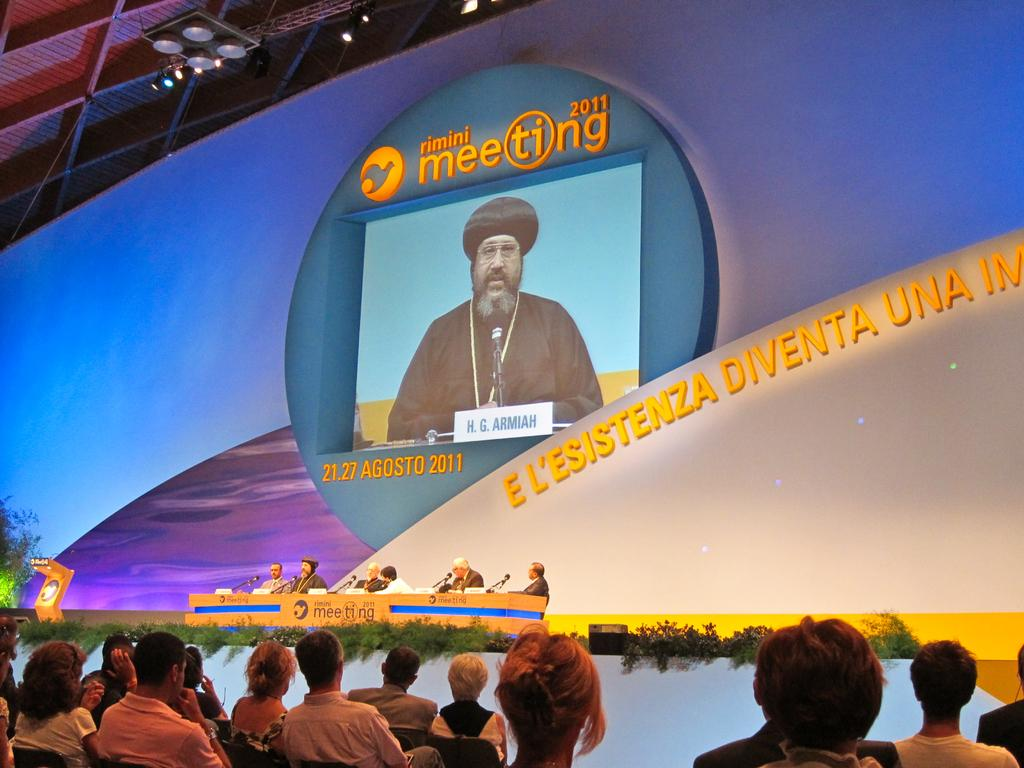Provide a one-sentence caption for the provided image. A crowd watching a large screen at the Rimini Meeting 2011. 